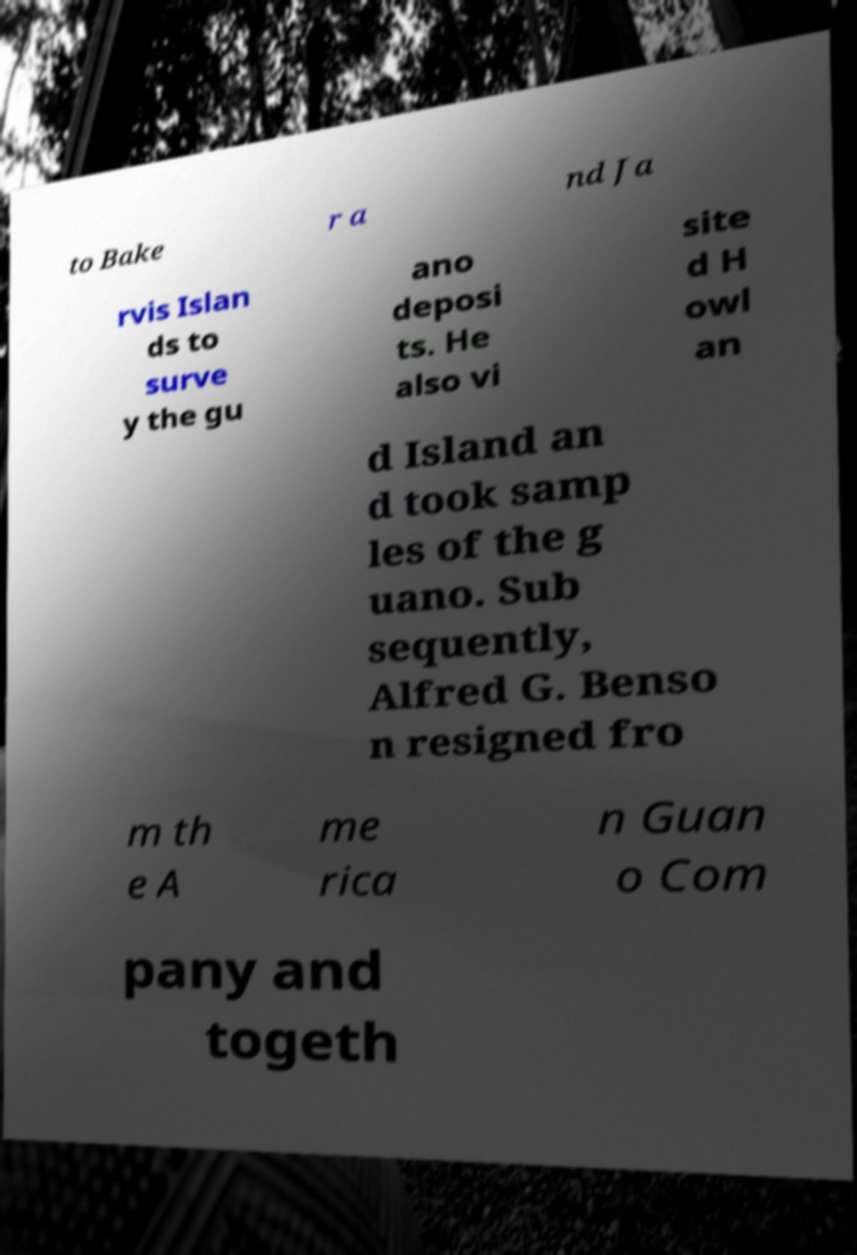What messages or text are displayed in this image? I need them in a readable, typed format. to Bake r a nd Ja rvis Islan ds to surve y the gu ano deposi ts. He also vi site d H owl an d Island an d took samp les of the g uano. Sub sequently, Alfred G. Benso n resigned fro m th e A me rica n Guan o Com pany and togeth 